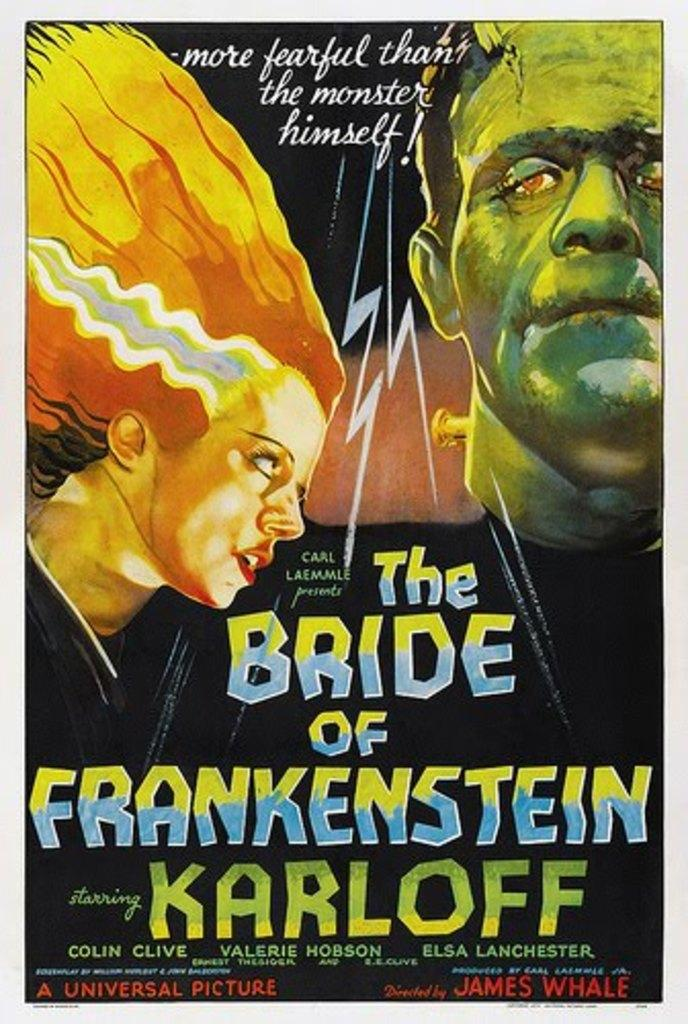<image>
Describe the image concisely. A movie poster for The Bride of Frankenstein stars Colin Clive. 